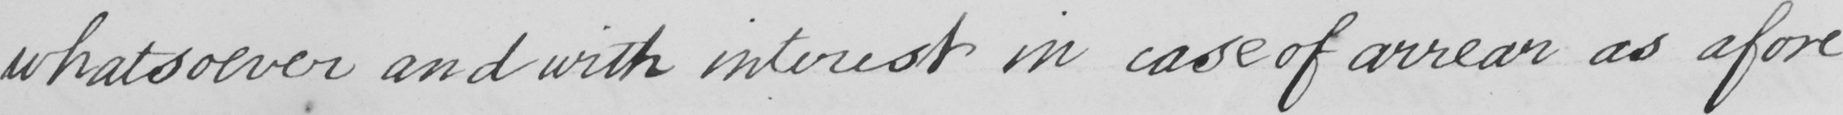Transcribe the text shown in this historical manuscript line. whatsoever and with interest in case of arrear as afore- 